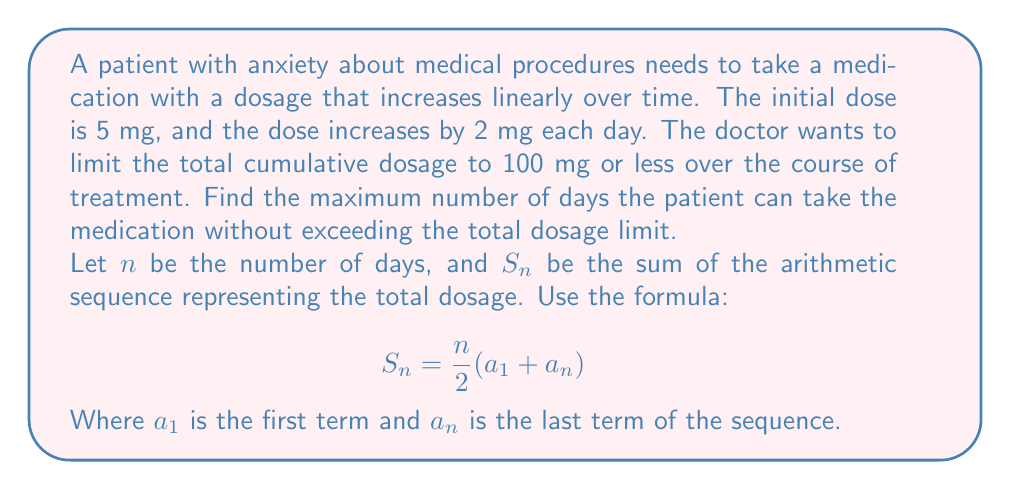Can you solve this math problem? Let's approach this step-by-step:

1) The sequence of daily doses forms an arithmetic sequence with:
   $a_1 = 5$ (initial dose)
   $d = 2$ (common difference)

2) The last term of the sequence, $a_n$, can be expressed as:
   $a_n = a_1 + (n-1)d = 5 + (n-1)2 = 5 + 2n - 2 = 2n + 3$

3) We can now use the formula for the sum of an arithmetic sequence:
   $$S_n = \frac{n}{2}(a_1 + a_n)$$

4) Substituting the values:
   $$S_n = \frac{n}{2}(5 + (2n + 3)) = \frac{n}{2}(2n + 8)$$

5) Simplifying:
   $$S_n = n^2 + 4n$$

6) We want to find the maximum $n$ where $S_n \leq 100$:
   $$n^2 + 4n \leq 100$$

7) Rearranging the inequality:
   $$n^2 + 4n - 100 \leq 0$$

8) This is a quadratic inequality. We can solve it by finding the roots of the quadratic equation:
   $$n^2 + 4n - 100 = 0$$

9) Using the quadratic formula, $n = \frac{-b \pm \sqrt{b^2 - 4ac}}{2a}$:
   $$n = \frac{-4 \pm \sqrt{16 + 400}}{2} = \frac{-4 \pm \sqrt{416}}{2} = \frac{-4 \pm 20.396}{2}$$

10) This gives us two roots: $n \approx 8.198$ or $n \approx -12.198$

11) Since $n$ represents days, it must be positive. The inequality is satisfied when $n \leq 8.198$

12) As $n$ must be a whole number, the maximum number of days is 8.
Answer: 8 days 